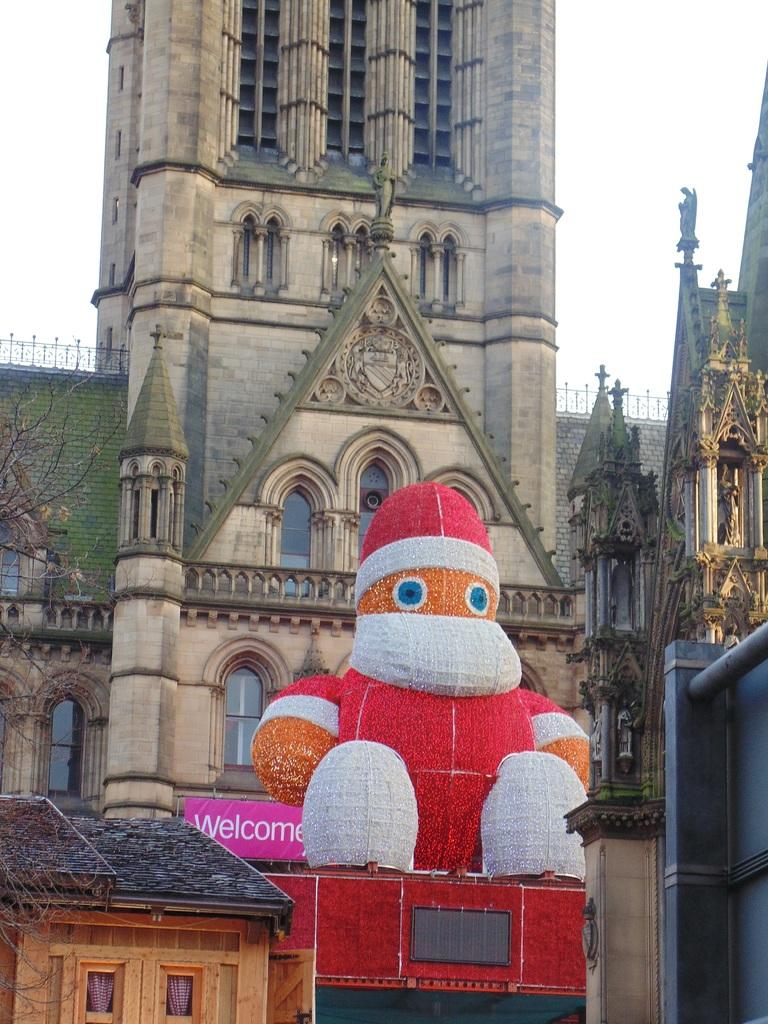What type of building is in the image? There is a church in the image. Who or what is in front of the church? There is a Santa Claus in front of the church. What can be seen in the background of the image? There is a sky visible in the background of the image. What is the rate at which the snails are moving in the image? There are no snails present in the image, so it is not possible to determine their rate of movement. 